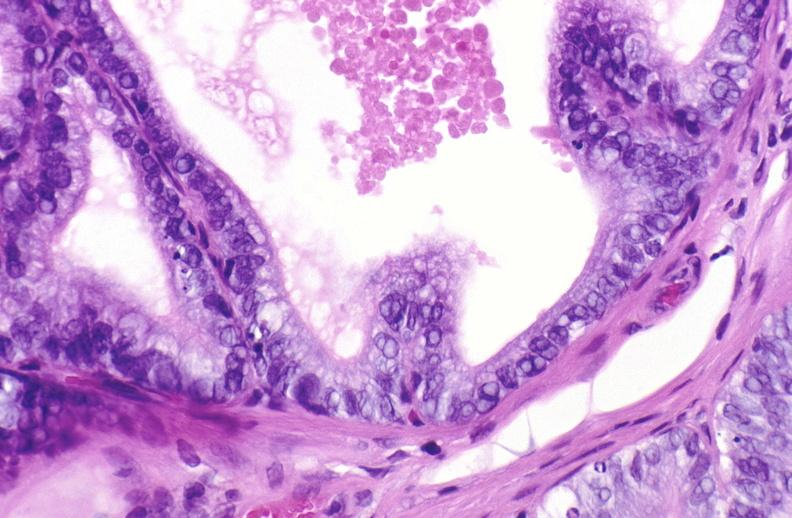what does this image show?
Answer the question using a single word or phrase. Apoptosis in prostate after orchiectomy 